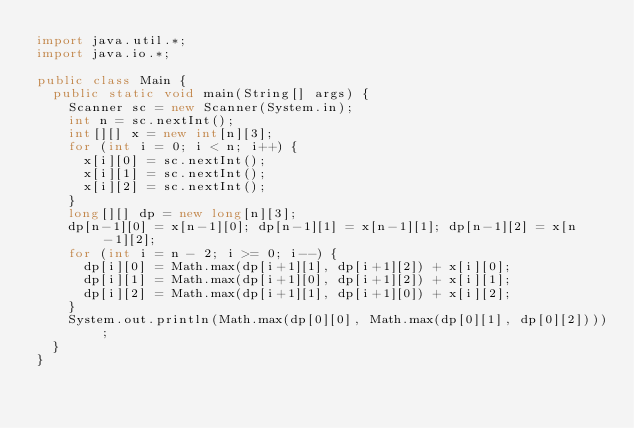Convert code to text. <code><loc_0><loc_0><loc_500><loc_500><_Java_>import java.util.*;
import java.io.*;

public class Main {
	public static void main(String[] args) {
		Scanner sc = new Scanner(System.in);
		int n = sc.nextInt();
		int[][] x = new int[n][3];
		for (int i = 0; i < n; i++) {
			x[i][0] = sc.nextInt();
			x[i][1] = sc.nextInt();
			x[i][2] = sc.nextInt();
		}
		long[][] dp = new long[n][3];
		dp[n-1][0] = x[n-1][0]; dp[n-1][1] = x[n-1][1]; dp[n-1][2] = x[n-1][2];
		for (int i = n - 2; i >= 0; i--) {
			dp[i][0] = Math.max(dp[i+1][1], dp[i+1][2]) + x[i][0];
			dp[i][1] = Math.max(dp[i+1][0], dp[i+1][2]) + x[i][1];
			dp[i][2] = Math.max(dp[i+1][1], dp[i+1][0]) + x[i][2];
		}
		System.out.println(Math.max(dp[0][0], Math.max(dp[0][1], dp[0][2])));
	}
}
</code> 